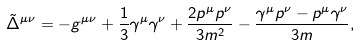Convert formula to latex. <formula><loc_0><loc_0><loc_500><loc_500>\tilde { \Delta } ^ { \mu \nu } = - g ^ { \mu \nu } + \frac { 1 } { 3 } \gamma ^ { \mu } \gamma ^ { \nu } + \frac { 2 p ^ { \mu } p ^ { \nu } } { 3 m ^ { 2 } } - \frac { \gamma ^ { \mu } p ^ { \nu } - p ^ { \mu } \gamma ^ { \nu } } { 3 m } ,</formula> 